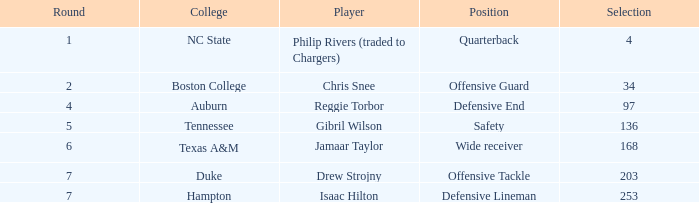Which Position has a Player of gibril wilson? Safety. Could you help me parse every detail presented in this table? {'header': ['Round', 'College', 'Player', 'Position', 'Selection'], 'rows': [['1', 'NC State', 'Philip Rivers (traded to Chargers)', 'Quarterback', '4'], ['2', 'Boston College', 'Chris Snee', 'Offensive Guard', '34'], ['4', 'Auburn', 'Reggie Torbor', 'Defensive End', '97'], ['5', 'Tennessee', 'Gibril Wilson', 'Safety', '136'], ['6', 'Texas A&M', 'Jamaar Taylor', 'Wide receiver', '168'], ['7', 'Duke', 'Drew Strojny', 'Offensive Tackle', '203'], ['7', 'Hampton', 'Isaac Hilton', 'Defensive Lineman', '253']]} 